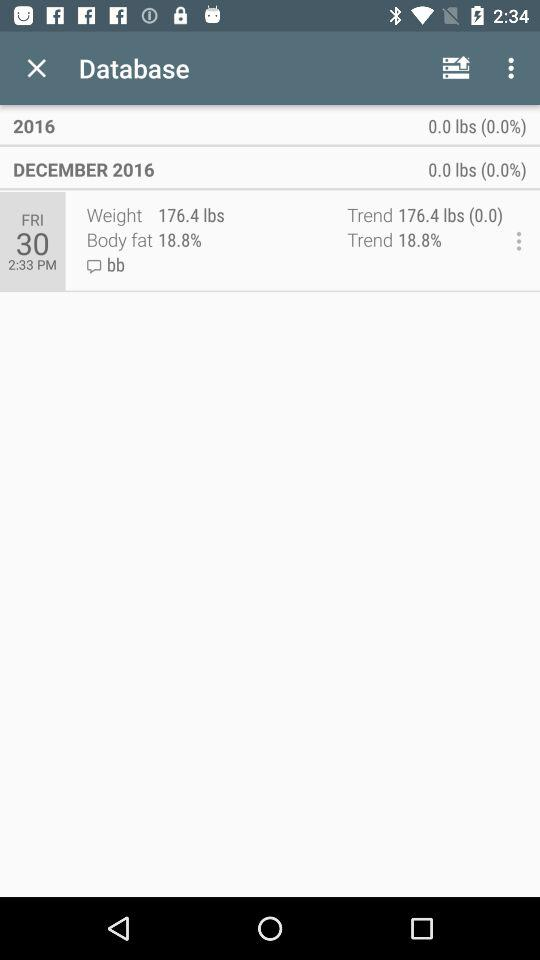What date is displayed on the screen? The date that is displayed on the screen is Friday, December 30, 2017. 